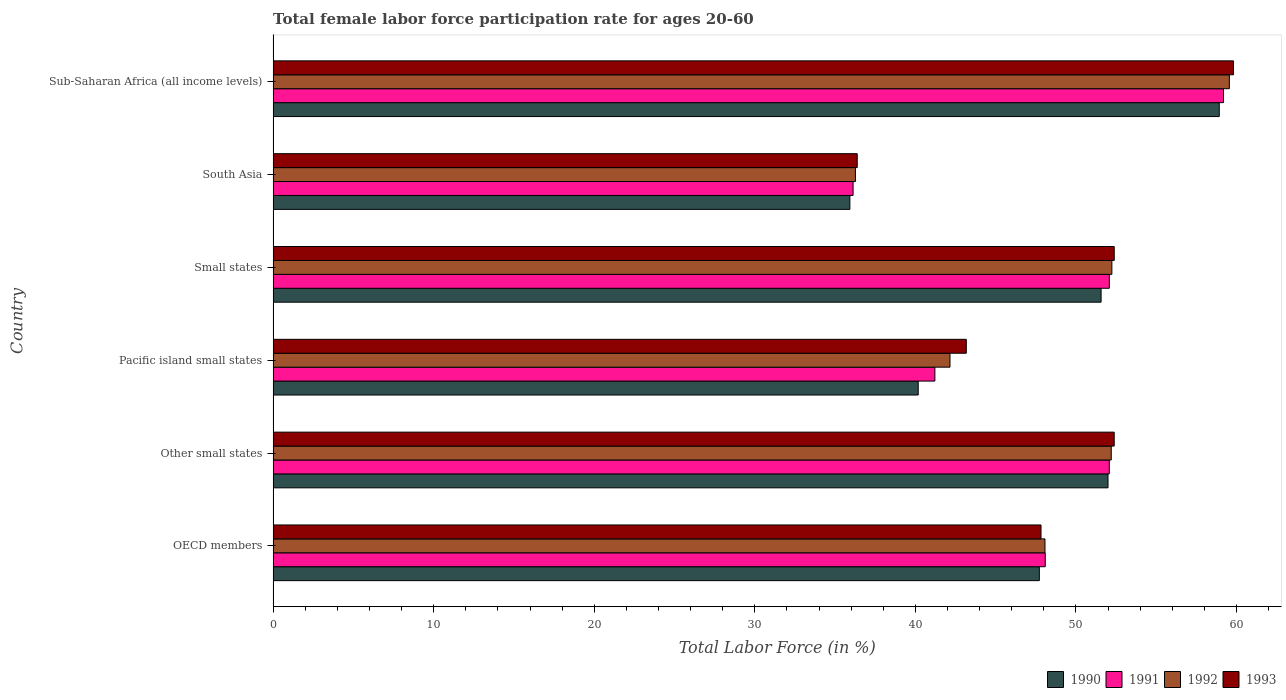How many different coloured bars are there?
Provide a short and direct response. 4. How many groups of bars are there?
Offer a terse response. 6. Are the number of bars on each tick of the Y-axis equal?
Provide a short and direct response. Yes. How many bars are there on the 3rd tick from the top?
Give a very brief answer. 4. How many bars are there on the 3rd tick from the bottom?
Your response must be concise. 4. What is the label of the 4th group of bars from the top?
Keep it short and to the point. Pacific island small states. In how many cases, is the number of bars for a given country not equal to the number of legend labels?
Offer a very short reply. 0. What is the female labor force participation rate in 1992 in OECD members?
Provide a succinct answer. 48.07. Across all countries, what is the maximum female labor force participation rate in 1991?
Give a very brief answer. 59.19. Across all countries, what is the minimum female labor force participation rate in 1992?
Your answer should be compact. 36.27. In which country was the female labor force participation rate in 1992 maximum?
Ensure brevity in your answer.  Sub-Saharan Africa (all income levels). What is the total female labor force participation rate in 1993 in the graph?
Provide a succinct answer. 291.94. What is the difference between the female labor force participation rate in 1993 in Small states and that in Sub-Saharan Africa (all income levels)?
Your answer should be compact. -7.43. What is the difference between the female labor force participation rate in 1990 in South Asia and the female labor force participation rate in 1993 in Sub-Saharan Africa (all income levels)?
Keep it short and to the point. -23.89. What is the average female labor force participation rate in 1992 per country?
Give a very brief answer. 48.41. What is the difference between the female labor force participation rate in 1993 and female labor force participation rate in 1992 in OECD members?
Keep it short and to the point. -0.25. What is the ratio of the female labor force participation rate in 1990 in OECD members to that in Pacific island small states?
Provide a succinct answer. 1.19. Is the female labor force participation rate in 1992 in OECD members less than that in South Asia?
Provide a succinct answer. No. What is the difference between the highest and the second highest female labor force participation rate in 1991?
Offer a terse response. 7.11. What is the difference between the highest and the lowest female labor force participation rate in 1990?
Your answer should be very brief. 23.01. In how many countries, is the female labor force participation rate in 1990 greater than the average female labor force participation rate in 1990 taken over all countries?
Offer a terse response. 4. Is the sum of the female labor force participation rate in 1992 in OECD members and Other small states greater than the maximum female labor force participation rate in 1990 across all countries?
Offer a terse response. Yes. What does the 1st bar from the top in Pacific island small states represents?
Your answer should be very brief. 1993. What does the 4th bar from the bottom in Pacific island small states represents?
Provide a short and direct response. 1993. Is it the case that in every country, the sum of the female labor force participation rate in 1990 and female labor force participation rate in 1993 is greater than the female labor force participation rate in 1991?
Keep it short and to the point. Yes. How many bars are there?
Give a very brief answer. 24. Are all the bars in the graph horizontal?
Keep it short and to the point. Yes. How many countries are there in the graph?
Provide a short and direct response. 6. What is the difference between two consecutive major ticks on the X-axis?
Your answer should be compact. 10. How many legend labels are there?
Keep it short and to the point. 4. How are the legend labels stacked?
Provide a short and direct response. Horizontal. What is the title of the graph?
Make the answer very short. Total female labor force participation rate for ages 20-60. What is the label or title of the Y-axis?
Give a very brief answer. Country. What is the Total Labor Force (in %) of 1990 in OECD members?
Give a very brief answer. 47.72. What is the Total Labor Force (in %) of 1991 in OECD members?
Your response must be concise. 48.09. What is the Total Labor Force (in %) in 1992 in OECD members?
Your response must be concise. 48.07. What is the Total Labor Force (in %) of 1993 in OECD members?
Offer a very short reply. 47.82. What is the Total Labor Force (in %) of 1990 in Other small states?
Ensure brevity in your answer.  52. What is the Total Labor Force (in %) in 1991 in Other small states?
Offer a very short reply. 52.08. What is the Total Labor Force (in %) in 1992 in Other small states?
Give a very brief answer. 52.2. What is the Total Labor Force (in %) of 1993 in Other small states?
Your answer should be compact. 52.38. What is the Total Labor Force (in %) in 1990 in Pacific island small states?
Provide a succinct answer. 40.18. What is the Total Labor Force (in %) in 1991 in Pacific island small states?
Offer a terse response. 41.21. What is the Total Labor Force (in %) of 1992 in Pacific island small states?
Ensure brevity in your answer.  42.15. What is the Total Labor Force (in %) in 1993 in Pacific island small states?
Provide a short and direct response. 43.17. What is the Total Labor Force (in %) of 1990 in Small states?
Make the answer very short. 51.57. What is the Total Labor Force (in %) of 1991 in Small states?
Your answer should be compact. 52.08. What is the Total Labor Force (in %) in 1992 in Small states?
Your answer should be compact. 52.24. What is the Total Labor Force (in %) in 1993 in Small states?
Your response must be concise. 52.38. What is the Total Labor Force (in %) in 1990 in South Asia?
Your answer should be very brief. 35.92. What is the Total Labor Force (in %) in 1991 in South Asia?
Provide a short and direct response. 36.12. What is the Total Labor Force (in %) in 1992 in South Asia?
Make the answer very short. 36.27. What is the Total Labor Force (in %) of 1993 in South Asia?
Ensure brevity in your answer.  36.38. What is the Total Labor Force (in %) of 1990 in Sub-Saharan Africa (all income levels)?
Keep it short and to the point. 58.92. What is the Total Labor Force (in %) in 1991 in Sub-Saharan Africa (all income levels)?
Your response must be concise. 59.19. What is the Total Labor Force (in %) of 1992 in Sub-Saharan Africa (all income levels)?
Ensure brevity in your answer.  59.55. What is the Total Labor Force (in %) in 1993 in Sub-Saharan Africa (all income levels)?
Give a very brief answer. 59.81. Across all countries, what is the maximum Total Labor Force (in %) of 1990?
Provide a succinct answer. 58.92. Across all countries, what is the maximum Total Labor Force (in %) in 1991?
Offer a terse response. 59.19. Across all countries, what is the maximum Total Labor Force (in %) of 1992?
Keep it short and to the point. 59.55. Across all countries, what is the maximum Total Labor Force (in %) of 1993?
Offer a very short reply. 59.81. Across all countries, what is the minimum Total Labor Force (in %) of 1990?
Provide a succinct answer. 35.92. Across all countries, what is the minimum Total Labor Force (in %) in 1991?
Your answer should be very brief. 36.12. Across all countries, what is the minimum Total Labor Force (in %) in 1992?
Provide a succinct answer. 36.27. Across all countries, what is the minimum Total Labor Force (in %) of 1993?
Offer a very short reply. 36.38. What is the total Total Labor Force (in %) of 1990 in the graph?
Your answer should be compact. 286.3. What is the total Total Labor Force (in %) of 1991 in the graph?
Provide a succinct answer. 288.76. What is the total Total Labor Force (in %) of 1992 in the graph?
Make the answer very short. 290.48. What is the total Total Labor Force (in %) in 1993 in the graph?
Your answer should be very brief. 291.94. What is the difference between the Total Labor Force (in %) in 1990 in OECD members and that in Other small states?
Your answer should be very brief. -4.28. What is the difference between the Total Labor Force (in %) in 1991 in OECD members and that in Other small states?
Keep it short and to the point. -3.99. What is the difference between the Total Labor Force (in %) of 1992 in OECD members and that in Other small states?
Ensure brevity in your answer.  -4.13. What is the difference between the Total Labor Force (in %) in 1993 in OECD members and that in Other small states?
Offer a terse response. -4.56. What is the difference between the Total Labor Force (in %) in 1990 in OECD members and that in Pacific island small states?
Your answer should be compact. 7.54. What is the difference between the Total Labor Force (in %) of 1991 in OECD members and that in Pacific island small states?
Your response must be concise. 6.87. What is the difference between the Total Labor Force (in %) in 1992 in OECD members and that in Pacific island small states?
Provide a short and direct response. 5.92. What is the difference between the Total Labor Force (in %) in 1993 in OECD members and that in Pacific island small states?
Give a very brief answer. 4.65. What is the difference between the Total Labor Force (in %) in 1990 in OECD members and that in Small states?
Make the answer very short. -3.85. What is the difference between the Total Labor Force (in %) of 1991 in OECD members and that in Small states?
Your response must be concise. -3.99. What is the difference between the Total Labor Force (in %) in 1992 in OECD members and that in Small states?
Keep it short and to the point. -4.17. What is the difference between the Total Labor Force (in %) of 1993 in OECD members and that in Small states?
Your answer should be very brief. -4.56. What is the difference between the Total Labor Force (in %) in 1990 in OECD members and that in South Asia?
Ensure brevity in your answer.  11.8. What is the difference between the Total Labor Force (in %) of 1991 in OECD members and that in South Asia?
Your answer should be compact. 11.97. What is the difference between the Total Labor Force (in %) in 1992 in OECD members and that in South Asia?
Ensure brevity in your answer.  11.8. What is the difference between the Total Labor Force (in %) in 1993 in OECD members and that in South Asia?
Offer a very short reply. 11.45. What is the difference between the Total Labor Force (in %) in 1990 in OECD members and that in Sub-Saharan Africa (all income levels)?
Ensure brevity in your answer.  -11.21. What is the difference between the Total Labor Force (in %) of 1991 in OECD members and that in Sub-Saharan Africa (all income levels)?
Offer a very short reply. -11.1. What is the difference between the Total Labor Force (in %) of 1992 in OECD members and that in Sub-Saharan Africa (all income levels)?
Your answer should be compact. -11.48. What is the difference between the Total Labor Force (in %) of 1993 in OECD members and that in Sub-Saharan Africa (all income levels)?
Your response must be concise. -11.99. What is the difference between the Total Labor Force (in %) of 1990 in Other small states and that in Pacific island small states?
Your answer should be compact. 11.82. What is the difference between the Total Labor Force (in %) of 1991 in Other small states and that in Pacific island small states?
Make the answer very short. 10.86. What is the difference between the Total Labor Force (in %) of 1992 in Other small states and that in Pacific island small states?
Your response must be concise. 10.04. What is the difference between the Total Labor Force (in %) in 1993 in Other small states and that in Pacific island small states?
Make the answer very short. 9.21. What is the difference between the Total Labor Force (in %) in 1990 in Other small states and that in Small states?
Give a very brief answer. 0.43. What is the difference between the Total Labor Force (in %) of 1991 in Other small states and that in Small states?
Provide a short and direct response. -0. What is the difference between the Total Labor Force (in %) of 1992 in Other small states and that in Small states?
Ensure brevity in your answer.  -0.04. What is the difference between the Total Labor Force (in %) in 1993 in Other small states and that in Small states?
Your response must be concise. -0. What is the difference between the Total Labor Force (in %) in 1990 in Other small states and that in South Asia?
Your answer should be very brief. 16.08. What is the difference between the Total Labor Force (in %) in 1991 in Other small states and that in South Asia?
Provide a succinct answer. 15.96. What is the difference between the Total Labor Force (in %) of 1992 in Other small states and that in South Asia?
Provide a succinct answer. 15.93. What is the difference between the Total Labor Force (in %) in 1993 in Other small states and that in South Asia?
Your response must be concise. 16. What is the difference between the Total Labor Force (in %) of 1990 in Other small states and that in Sub-Saharan Africa (all income levels)?
Your response must be concise. -6.93. What is the difference between the Total Labor Force (in %) in 1991 in Other small states and that in Sub-Saharan Africa (all income levels)?
Keep it short and to the point. -7.11. What is the difference between the Total Labor Force (in %) in 1992 in Other small states and that in Sub-Saharan Africa (all income levels)?
Ensure brevity in your answer.  -7.36. What is the difference between the Total Labor Force (in %) in 1993 in Other small states and that in Sub-Saharan Africa (all income levels)?
Your response must be concise. -7.43. What is the difference between the Total Labor Force (in %) in 1990 in Pacific island small states and that in Small states?
Make the answer very short. -11.39. What is the difference between the Total Labor Force (in %) in 1991 in Pacific island small states and that in Small states?
Your response must be concise. -10.86. What is the difference between the Total Labor Force (in %) in 1992 in Pacific island small states and that in Small states?
Keep it short and to the point. -10.08. What is the difference between the Total Labor Force (in %) in 1993 in Pacific island small states and that in Small states?
Give a very brief answer. -9.21. What is the difference between the Total Labor Force (in %) of 1990 in Pacific island small states and that in South Asia?
Offer a terse response. 4.26. What is the difference between the Total Labor Force (in %) in 1991 in Pacific island small states and that in South Asia?
Provide a succinct answer. 5.1. What is the difference between the Total Labor Force (in %) in 1992 in Pacific island small states and that in South Asia?
Give a very brief answer. 5.89. What is the difference between the Total Labor Force (in %) in 1993 in Pacific island small states and that in South Asia?
Your response must be concise. 6.79. What is the difference between the Total Labor Force (in %) in 1990 in Pacific island small states and that in Sub-Saharan Africa (all income levels)?
Make the answer very short. -18.75. What is the difference between the Total Labor Force (in %) of 1991 in Pacific island small states and that in Sub-Saharan Africa (all income levels)?
Provide a short and direct response. -17.97. What is the difference between the Total Labor Force (in %) in 1992 in Pacific island small states and that in Sub-Saharan Africa (all income levels)?
Offer a very short reply. -17.4. What is the difference between the Total Labor Force (in %) of 1993 in Pacific island small states and that in Sub-Saharan Africa (all income levels)?
Provide a short and direct response. -16.64. What is the difference between the Total Labor Force (in %) in 1990 in Small states and that in South Asia?
Make the answer very short. 15.65. What is the difference between the Total Labor Force (in %) in 1991 in Small states and that in South Asia?
Provide a short and direct response. 15.96. What is the difference between the Total Labor Force (in %) in 1992 in Small states and that in South Asia?
Give a very brief answer. 15.97. What is the difference between the Total Labor Force (in %) in 1993 in Small states and that in South Asia?
Give a very brief answer. 16.01. What is the difference between the Total Labor Force (in %) in 1990 in Small states and that in Sub-Saharan Africa (all income levels)?
Give a very brief answer. -7.36. What is the difference between the Total Labor Force (in %) in 1991 in Small states and that in Sub-Saharan Africa (all income levels)?
Offer a very short reply. -7.11. What is the difference between the Total Labor Force (in %) of 1992 in Small states and that in Sub-Saharan Africa (all income levels)?
Give a very brief answer. -7.32. What is the difference between the Total Labor Force (in %) of 1993 in Small states and that in Sub-Saharan Africa (all income levels)?
Offer a terse response. -7.43. What is the difference between the Total Labor Force (in %) of 1990 in South Asia and that in Sub-Saharan Africa (all income levels)?
Provide a short and direct response. -23.01. What is the difference between the Total Labor Force (in %) of 1991 in South Asia and that in Sub-Saharan Africa (all income levels)?
Give a very brief answer. -23.07. What is the difference between the Total Labor Force (in %) of 1992 in South Asia and that in Sub-Saharan Africa (all income levels)?
Offer a very short reply. -23.29. What is the difference between the Total Labor Force (in %) of 1993 in South Asia and that in Sub-Saharan Africa (all income levels)?
Your answer should be very brief. -23.43. What is the difference between the Total Labor Force (in %) in 1990 in OECD members and the Total Labor Force (in %) in 1991 in Other small states?
Give a very brief answer. -4.36. What is the difference between the Total Labor Force (in %) of 1990 in OECD members and the Total Labor Force (in %) of 1992 in Other small states?
Offer a very short reply. -4.48. What is the difference between the Total Labor Force (in %) of 1990 in OECD members and the Total Labor Force (in %) of 1993 in Other small states?
Keep it short and to the point. -4.66. What is the difference between the Total Labor Force (in %) in 1991 in OECD members and the Total Labor Force (in %) in 1992 in Other small states?
Keep it short and to the point. -4.11. What is the difference between the Total Labor Force (in %) in 1991 in OECD members and the Total Labor Force (in %) in 1993 in Other small states?
Your answer should be compact. -4.29. What is the difference between the Total Labor Force (in %) of 1992 in OECD members and the Total Labor Force (in %) of 1993 in Other small states?
Ensure brevity in your answer.  -4.31. What is the difference between the Total Labor Force (in %) of 1990 in OECD members and the Total Labor Force (in %) of 1991 in Pacific island small states?
Make the answer very short. 6.5. What is the difference between the Total Labor Force (in %) of 1990 in OECD members and the Total Labor Force (in %) of 1992 in Pacific island small states?
Provide a short and direct response. 5.57. What is the difference between the Total Labor Force (in %) in 1990 in OECD members and the Total Labor Force (in %) in 1993 in Pacific island small states?
Your answer should be very brief. 4.55. What is the difference between the Total Labor Force (in %) of 1991 in OECD members and the Total Labor Force (in %) of 1992 in Pacific island small states?
Keep it short and to the point. 5.93. What is the difference between the Total Labor Force (in %) in 1991 in OECD members and the Total Labor Force (in %) in 1993 in Pacific island small states?
Provide a succinct answer. 4.92. What is the difference between the Total Labor Force (in %) of 1992 in OECD members and the Total Labor Force (in %) of 1993 in Pacific island small states?
Your response must be concise. 4.9. What is the difference between the Total Labor Force (in %) in 1990 in OECD members and the Total Labor Force (in %) in 1991 in Small states?
Provide a short and direct response. -4.36. What is the difference between the Total Labor Force (in %) in 1990 in OECD members and the Total Labor Force (in %) in 1992 in Small states?
Your response must be concise. -4.52. What is the difference between the Total Labor Force (in %) in 1990 in OECD members and the Total Labor Force (in %) in 1993 in Small states?
Make the answer very short. -4.66. What is the difference between the Total Labor Force (in %) of 1991 in OECD members and the Total Labor Force (in %) of 1992 in Small states?
Keep it short and to the point. -4.15. What is the difference between the Total Labor Force (in %) in 1991 in OECD members and the Total Labor Force (in %) in 1993 in Small states?
Provide a succinct answer. -4.29. What is the difference between the Total Labor Force (in %) in 1992 in OECD members and the Total Labor Force (in %) in 1993 in Small states?
Ensure brevity in your answer.  -4.31. What is the difference between the Total Labor Force (in %) in 1990 in OECD members and the Total Labor Force (in %) in 1991 in South Asia?
Give a very brief answer. 11.6. What is the difference between the Total Labor Force (in %) of 1990 in OECD members and the Total Labor Force (in %) of 1992 in South Asia?
Provide a short and direct response. 11.45. What is the difference between the Total Labor Force (in %) of 1990 in OECD members and the Total Labor Force (in %) of 1993 in South Asia?
Offer a very short reply. 11.34. What is the difference between the Total Labor Force (in %) of 1991 in OECD members and the Total Labor Force (in %) of 1992 in South Asia?
Make the answer very short. 11.82. What is the difference between the Total Labor Force (in %) of 1991 in OECD members and the Total Labor Force (in %) of 1993 in South Asia?
Ensure brevity in your answer.  11.71. What is the difference between the Total Labor Force (in %) in 1992 in OECD members and the Total Labor Force (in %) in 1993 in South Asia?
Provide a succinct answer. 11.69. What is the difference between the Total Labor Force (in %) of 1990 in OECD members and the Total Labor Force (in %) of 1991 in Sub-Saharan Africa (all income levels)?
Your answer should be compact. -11.47. What is the difference between the Total Labor Force (in %) of 1990 in OECD members and the Total Labor Force (in %) of 1992 in Sub-Saharan Africa (all income levels)?
Keep it short and to the point. -11.83. What is the difference between the Total Labor Force (in %) of 1990 in OECD members and the Total Labor Force (in %) of 1993 in Sub-Saharan Africa (all income levels)?
Provide a succinct answer. -12.09. What is the difference between the Total Labor Force (in %) in 1991 in OECD members and the Total Labor Force (in %) in 1992 in Sub-Saharan Africa (all income levels)?
Your response must be concise. -11.46. What is the difference between the Total Labor Force (in %) of 1991 in OECD members and the Total Labor Force (in %) of 1993 in Sub-Saharan Africa (all income levels)?
Your response must be concise. -11.72. What is the difference between the Total Labor Force (in %) of 1992 in OECD members and the Total Labor Force (in %) of 1993 in Sub-Saharan Africa (all income levels)?
Provide a succinct answer. -11.74. What is the difference between the Total Labor Force (in %) in 1990 in Other small states and the Total Labor Force (in %) in 1991 in Pacific island small states?
Your response must be concise. 10.78. What is the difference between the Total Labor Force (in %) in 1990 in Other small states and the Total Labor Force (in %) in 1992 in Pacific island small states?
Your answer should be compact. 9.84. What is the difference between the Total Labor Force (in %) of 1990 in Other small states and the Total Labor Force (in %) of 1993 in Pacific island small states?
Offer a terse response. 8.83. What is the difference between the Total Labor Force (in %) of 1991 in Other small states and the Total Labor Force (in %) of 1992 in Pacific island small states?
Your response must be concise. 9.92. What is the difference between the Total Labor Force (in %) in 1991 in Other small states and the Total Labor Force (in %) in 1993 in Pacific island small states?
Make the answer very short. 8.91. What is the difference between the Total Labor Force (in %) of 1992 in Other small states and the Total Labor Force (in %) of 1993 in Pacific island small states?
Make the answer very short. 9.03. What is the difference between the Total Labor Force (in %) in 1990 in Other small states and the Total Labor Force (in %) in 1991 in Small states?
Your response must be concise. -0.08. What is the difference between the Total Labor Force (in %) in 1990 in Other small states and the Total Labor Force (in %) in 1992 in Small states?
Keep it short and to the point. -0.24. What is the difference between the Total Labor Force (in %) of 1990 in Other small states and the Total Labor Force (in %) of 1993 in Small states?
Your response must be concise. -0.39. What is the difference between the Total Labor Force (in %) in 1991 in Other small states and the Total Labor Force (in %) in 1992 in Small states?
Your answer should be compact. -0.16. What is the difference between the Total Labor Force (in %) in 1991 in Other small states and the Total Labor Force (in %) in 1993 in Small states?
Make the answer very short. -0.31. What is the difference between the Total Labor Force (in %) of 1992 in Other small states and the Total Labor Force (in %) of 1993 in Small states?
Your answer should be very brief. -0.19. What is the difference between the Total Labor Force (in %) of 1990 in Other small states and the Total Labor Force (in %) of 1991 in South Asia?
Ensure brevity in your answer.  15.88. What is the difference between the Total Labor Force (in %) of 1990 in Other small states and the Total Labor Force (in %) of 1992 in South Asia?
Provide a short and direct response. 15.73. What is the difference between the Total Labor Force (in %) in 1990 in Other small states and the Total Labor Force (in %) in 1993 in South Asia?
Give a very brief answer. 15.62. What is the difference between the Total Labor Force (in %) of 1991 in Other small states and the Total Labor Force (in %) of 1992 in South Asia?
Make the answer very short. 15.81. What is the difference between the Total Labor Force (in %) in 1991 in Other small states and the Total Labor Force (in %) in 1993 in South Asia?
Ensure brevity in your answer.  15.7. What is the difference between the Total Labor Force (in %) of 1992 in Other small states and the Total Labor Force (in %) of 1993 in South Asia?
Provide a short and direct response. 15.82. What is the difference between the Total Labor Force (in %) in 1990 in Other small states and the Total Labor Force (in %) in 1991 in Sub-Saharan Africa (all income levels)?
Ensure brevity in your answer.  -7.19. What is the difference between the Total Labor Force (in %) in 1990 in Other small states and the Total Labor Force (in %) in 1992 in Sub-Saharan Africa (all income levels)?
Your answer should be compact. -7.56. What is the difference between the Total Labor Force (in %) in 1990 in Other small states and the Total Labor Force (in %) in 1993 in Sub-Saharan Africa (all income levels)?
Offer a terse response. -7.81. What is the difference between the Total Labor Force (in %) of 1991 in Other small states and the Total Labor Force (in %) of 1992 in Sub-Saharan Africa (all income levels)?
Provide a succinct answer. -7.48. What is the difference between the Total Labor Force (in %) in 1991 in Other small states and the Total Labor Force (in %) in 1993 in Sub-Saharan Africa (all income levels)?
Keep it short and to the point. -7.73. What is the difference between the Total Labor Force (in %) in 1992 in Other small states and the Total Labor Force (in %) in 1993 in Sub-Saharan Africa (all income levels)?
Your response must be concise. -7.61. What is the difference between the Total Labor Force (in %) in 1990 in Pacific island small states and the Total Labor Force (in %) in 1991 in Small states?
Offer a terse response. -11.9. What is the difference between the Total Labor Force (in %) in 1990 in Pacific island small states and the Total Labor Force (in %) in 1992 in Small states?
Keep it short and to the point. -12.06. What is the difference between the Total Labor Force (in %) in 1990 in Pacific island small states and the Total Labor Force (in %) in 1993 in Small states?
Offer a terse response. -12.21. What is the difference between the Total Labor Force (in %) of 1991 in Pacific island small states and the Total Labor Force (in %) of 1992 in Small states?
Offer a terse response. -11.02. What is the difference between the Total Labor Force (in %) in 1991 in Pacific island small states and the Total Labor Force (in %) in 1993 in Small states?
Provide a short and direct response. -11.17. What is the difference between the Total Labor Force (in %) in 1992 in Pacific island small states and the Total Labor Force (in %) in 1993 in Small states?
Ensure brevity in your answer.  -10.23. What is the difference between the Total Labor Force (in %) of 1990 in Pacific island small states and the Total Labor Force (in %) of 1991 in South Asia?
Provide a short and direct response. 4.06. What is the difference between the Total Labor Force (in %) in 1990 in Pacific island small states and the Total Labor Force (in %) in 1992 in South Asia?
Your response must be concise. 3.91. What is the difference between the Total Labor Force (in %) of 1990 in Pacific island small states and the Total Labor Force (in %) of 1993 in South Asia?
Offer a very short reply. 3.8. What is the difference between the Total Labor Force (in %) of 1991 in Pacific island small states and the Total Labor Force (in %) of 1992 in South Asia?
Offer a very short reply. 4.95. What is the difference between the Total Labor Force (in %) in 1991 in Pacific island small states and the Total Labor Force (in %) in 1993 in South Asia?
Give a very brief answer. 4.84. What is the difference between the Total Labor Force (in %) in 1992 in Pacific island small states and the Total Labor Force (in %) in 1993 in South Asia?
Provide a short and direct response. 5.78. What is the difference between the Total Labor Force (in %) of 1990 in Pacific island small states and the Total Labor Force (in %) of 1991 in Sub-Saharan Africa (all income levels)?
Your answer should be very brief. -19.01. What is the difference between the Total Labor Force (in %) of 1990 in Pacific island small states and the Total Labor Force (in %) of 1992 in Sub-Saharan Africa (all income levels)?
Provide a short and direct response. -19.38. What is the difference between the Total Labor Force (in %) in 1990 in Pacific island small states and the Total Labor Force (in %) in 1993 in Sub-Saharan Africa (all income levels)?
Your answer should be very brief. -19.63. What is the difference between the Total Labor Force (in %) of 1991 in Pacific island small states and the Total Labor Force (in %) of 1992 in Sub-Saharan Africa (all income levels)?
Give a very brief answer. -18.34. What is the difference between the Total Labor Force (in %) of 1991 in Pacific island small states and the Total Labor Force (in %) of 1993 in Sub-Saharan Africa (all income levels)?
Provide a succinct answer. -18.59. What is the difference between the Total Labor Force (in %) of 1992 in Pacific island small states and the Total Labor Force (in %) of 1993 in Sub-Saharan Africa (all income levels)?
Your response must be concise. -17.66. What is the difference between the Total Labor Force (in %) of 1990 in Small states and the Total Labor Force (in %) of 1991 in South Asia?
Your answer should be very brief. 15.45. What is the difference between the Total Labor Force (in %) of 1990 in Small states and the Total Labor Force (in %) of 1992 in South Asia?
Make the answer very short. 15.3. What is the difference between the Total Labor Force (in %) in 1990 in Small states and the Total Labor Force (in %) in 1993 in South Asia?
Provide a short and direct response. 15.19. What is the difference between the Total Labor Force (in %) in 1991 in Small states and the Total Labor Force (in %) in 1992 in South Asia?
Give a very brief answer. 15.81. What is the difference between the Total Labor Force (in %) in 1991 in Small states and the Total Labor Force (in %) in 1993 in South Asia?
Your answer should be compact. 15.7. What is the difference between the Total Labor Force (in %) in 1992 in Small states and the Total Labor Force (in %) in 1993 in South Asia?
Your answer should be compact. 15.86. What is the difference between the Total Labor Force (in %) of 1990 in Small states and the Total Labor Force (in %) of 1991 in Sub-Saharan Africa (all income levels)?
Offer a very short reply. -7.62. What is the difference between the Total Labor Force (in %) of 1990 in Small states and the Total Labor Force (in %) of 1992 in Sub-Saharan Africa (all income levels)?
Provide a succinct answer. -7.99. What is the difference between the Total Labor Force (in %) of 1990 in Small states and the Total Labor Force (in %) of 1993 in Sub-Saharan Africa (all income levels)?
Your answer should be very brief. -8.24. What is the difference between the Total Labor Force (in %) in 1991 in Small states and the Total Labor Force (in %) in 1992 in Sub-Saharan Africa (all income levels)?
Make the answer very short. -7.47. What is the difference between the Total Labor Force (in %) of 1991 in Small states and the Total Labor Force (in %) of 1993 in Sub-Saharan Africa (all income levels)?
Keep it short and to the point. -7.73. What is the difference between the Total Labor Force (in %) of 1992 in Small states and the Total Labor Force (in %) of 1993 in Sub-Saharan Africa (all income levels)?
Provide a succinct answer. -7.57. What is the difference between the Total Labor Force (in %) in 1990 in South Asia and the Total Labor Force (in %) in 1991 in Sub-Saharan Africa (all income levels)?
Provide a succinct answer. -23.27. What is the difference between the Total Labor Force (in %) in 1990 in South Asia and the Total Labor Force (in %) in 1992 in Sub-Saharan Africa (all income levels)?
Your response must be concise. -23.63. What is the difference between the Total Labor Force (in %) in 1990 in South Asia and the Total Labor Force (in %) in 1993 in Sub-Saharan Africa (all income levels)?
Make the answer very short. -23.89. What is the difference between the Total Labor Force (in %) in 1991 in South Asia and the Total Labor Force (in %) in 1992 in Sub-Saharan Africa (all income levels)?
Offer a very short reply. -23.43. What is the difference between the Total Labor Force (in %) of 1991 in South Asia and the Total Labor Force (in %) of 1993 in Sub-Saharan Africa (all income levels)?
Keep it short and to the point. -23.69. What is the difference between the Total Labor Force (in %) of 1992 in South Asia and the Total Labor Force (in %) of 1993 in Sub-Saharan Africa (all income levels)?
Your response must be concise. -23.54. What is the average Total Labor Force (in %) in 1990 per country?
Your response must be concise. 47.72. What is the average Total Labor Force (in %) of 1991 per country?
Your answer should be compact. 48.13. What is the average Total Labor Force (in %) in 1992 per country?
Your answer should be compact. 48.41. What is the average Total Labor Force (in %) in 1993 per country?
Your answer should be very brief. 48.66. What is the difference between the Total Labor Force (in %) in 1990 and Total Labor Force (in %) in 1991 in OECD members?
Ensure brevity in your answer.  -0.37. What is the difference between the Total Labor Force (in %) of 1990 and Total Labor Force (in %) of 1992 in OECD members?
Ensure brevity in your answer.  -0.35. What is the difference between the Total Labor Force (in %) of 1990 and Total Labor Force (in %) of 1993 in OECD members?
Your response must be concise. -0.1. What is the difference between the Total Labor Force (in %) in 1991 and Total Labor Force (in %) in 1992 in OECD members?
Keep it short and to the point. 0.02. What is the difference between the Total Labor Force (in %) of 1991 and Total Labor Force (in %) of 1993 in OECD members?
Give a very brief answer. 0.27. What is the difference between the Total Labor Force (in %) of 1992 and Total Labor Force (in %) of 1993 in OECD members?
Make the answer very short. 0.25. What is the difference between the Total Labor Force (in %) of 1990 and Total Labor Force (in %) of 1991 in Other small states?
Offer a very short reply. -0.08. What is the difference between the Total Labor Force (in %) of 1990 and Total Labor Force (in %) of 1992 in Other small states?
Ensure brevity in your answer.  -0.2. What is the difference between the Total Labor Force (in %) in 1990 and Total Labor Force (in %) in 1993 in Other small states?
Offer a terse response. -0.39. What is the difference between the Total Labor Force (in %) of 1991 and Total Labor Force (in %) of 1992 in Other small states?
Provide a succinct answer. -0.12. What is the difference between the Total Labor Force (in %) of 1991 and Total Labor Force (in %) of 1993 in Other small states?
Make the answer very short. -0.31. What is the difference between the Total Labor Force (in %) of 1992 and Total Labor Force (in %) of 1993 in Other small states?
Make the answer very short. -0.18. What is the difference between the Total Labor Force (in %) in 1990 and Total Labor Force (in %) in 1991 in Pacific island small states?
Give a very brief answer. -1.04. What is the difference between the Total Labor Force (in %) in 1990 and Total Labor Force (in %) in 1992 in Pacific island small states?
Your answer should be compact. -1.98. What is the difference between the Total Labor Force (in %) of 1990 and Total Labor Force (in %) of 1993 in Pacific island small states?
Make the answer very short. -2.99. What is the difference between the Total Labor Force (in %) of 1991 and Total Labor Force (in %) of 1992 in Pacific island small states?
Provide a succinct answer. -0.94. What is the difference between the Total Labor Force (in %) of 1991 and Total Labor Force (in %) of 1993 in Pacific island small states?
Provide a succinct answer. -1.96. What is the difference between the Total Labor Force (in %) in 1992 and Total Labor Force (in %) in 1993 in Pacific island small states?
Ensure brevity in your answer.  -1.02. What is the difference between the Total Labor Force (in %) of 1990 and Total Labor Force (in %) of 1991 in Small states?
Provide a short and direct response. -0.51. What is the difference between the Total Labor Force (in %) in 1990 and Total Labor Force (in %) in 1992 in Small states?
Make the answer very short. -0.67. What is the difference between the Total Labor Force (in %) of 1990 and Total Labor Force (in %) of 1993 in Small states?
Make the answer very short. -0.82. What is the difference between the Total Labor Force (in %) in 1991 and Total Labor Force (in %) in 1992 in Small states?
Offer a very short reply. -0.16. What is the difference between the Total Labor Force (in %) in 1991 and Total Labor Force (in %) in 1993 in Small states?
Give a very brief answer. -0.3. What is the difference between the Total Labor Force (in %) of 1992 and Total Labor Force (in %) of 1993 in Small states?
Your answer should be compact. -0.15. What is the difference between the Total Labor Force (in %) in 1990 and Total Labor Force (in %) in 1991 in South Asia?
Give a very brief answer. -0.2. What is the difference between the Total Labor Force (in %) of 1990 and Total Labor Force (in %) of 1992 in South Asia?
Offer a terse response. -0.35. What is the difference between the Total Labor Force (in %) in 1990 and Total Labor Force (in %) in 1993 in South Asia?
Provide a succinct answer. -0.46. What is the difference between the Total Labor Force (in %) of 1991 and Total Labor Force (in %) of 1992 in South Asia?
Give a very brief answer. -0.15. What is the difference between the Total Labor Force (in %) of 1991 and Total Labor Force (in %) of 1993 in South Asia?
Offer a very short reply. -0.26. What is the difference between the Total Labor Force (in %) in 1992 and Total Labor Force (in %) in 1993 in South Asia?
Make the answer very short. -0.11. What is the difference between the Total Labor Force (in %) of 1990 and Total Labor Force (in %) of 1991 in Sub-Saharan Africa (all income levels)?
Keep it short and to the point. -0.26. What is the difference between the Total Labor Force (in %) in 1990 and Total Labor Force (in %) in 1992 in Sub-Saharan Africa (all income levels)?
Make the answer very short. -0.63. What is the difference between the Total Labor Force (in %) in 1990 and Total Labor Force (in %) in 1993 in Sub-Saharan Africa (all income levels)?
Your response must be concise. -0.88. What is the difference between the Total Labor Force (in %) in 1991 and Total Labor Force (in %) in 1992 in Sub-Saharan Africa (all income levels)?
Provide a short and direct response. -0.36. What is the difference between the Total Labor Force (in %) of 1991 and Total Labor Force (in %) of 1993 in Sub-Saharan Africa (all income levels)?
Ensure brevity in your answer.  -0.62. What is the difference between the Total Labor Force (in %) in 1992 and Total Labor Force (in %) in 1993 in Sub-Saharan Africa (all income levels)?
Offer a terse response. -0.26. What is the ratio of the Total Labor Force (in %) in 1990 in OECD members to that in Other small states?
Provide a succinct answer. 0.92. What is the ratio of the Total Labor Force (in %) in 1991 in OECD members to that in Other small states?
Ensure brevity in your answer.  0.92. What is the ratio of the Total Labor Force (in %) in 1992 in OECD members to that in Other small states?
Make the answer very short. 0.92. What is the ratio of the Total Labor Force (in %) in 1993 in OECD members to that in Other small states?
Your answer should be very brief. 0.91. What is the ratio of the Total Labor Force (in %) in 1990 in OECD members to that in Pacific island small states?
Your answer should be very brief. 1.19. What is the ratio of the Total Labor Force (in %) of 1991 in OECD members to that in Pacific island small states?
Your answer should be compact. 1.17. What is the ratio of the Total Labor Force (in %) of 1992 in OECD members to that in Pacific island small states?
Your response must be concise. 1.14. What is the ratio of the Total Labor Force (in %) of 1993 in OECD members to that in Pacific island small states?
Ensure brevity in your answer.  1.11. What is the ratio of the Total Labor Force (in %) of 1990 in OECD members to that in Small states?
Offer a terse response. 0.93. What is the ratio of the Total Labor Force (in %) in 1991 in OECD members to that in Small states?
Your answer should be very brief. 0.92. What is the ratio of the Total Labor Force (in %) of 1992 in OECD members to that in Small states?
Make the answer very short. 0.92. What is the ratio of the Total Labor Force (in %) of 1993 in OECD members to that in Small states?
Offer a terse response. 0.91. What is the ratio of the Total Labor Force (in %) in 1990 in OECD members to that in South Asia?
Give a very brief answer. 1.33. What is the ratio of the Total Labor Force (in %) of 1991 in OECD members to that in South Asia?
Provide a succinct answer. 1.33. What is the ratio of the Total Labor Force (in %) in 1992 in OECD members to that in South Asia?
Give a very brief answer. 1.33. What is the ratio of the Total Labor Force (in %) in 1993 in OECD members to that in South Asia?
Provide a succinct answer. 1.31. What is the ratio of the Total Labor Force (in %) of 1990 in OECD members to that in Sub-Saharan Africa (all income levels)?
Your response must be concise. 0.81. What is the ratio of the Total Labor Force (in %) in 1991 in OECD members to that in Sub-Saharan Africa (all income levels)?
Your answer should be very brief. 0.81. What is the ratio of the Total Labor Force (in %) of 1992 in OECD members to that in Sub-Saharan Africa (all income levels)?
Keep it short and to the point. 0.81. What is the ratio of the Total Labor Force (in %) of 1993 in OECD members to that in Sub-Saharan Africa (all income levels)?
Give a very brief answer. 0.8. What is the ratio of the Total Labor Force (in %) in 1990 in Other small states to that in Pacific island small states?
Your answer should be compact. 1.29. What is the ratio of the Total Labor Force (in %) in 1991 in Other small states to that in Pacific island small states?
Provide a short and direct response. 1.26. What is the ratio of the Total Labor Force (in %) in 1992 in Other small states to that in Pacific island small states?
Your answer should be very brief. 1.24. What is the ratio of the Total Labor Force (in %) in 1993 in Other small states to that in Pacific island small states?
Provide a succinct answer. 1.21. What is the ratio of the Total Labor Force (in %) of 1990 in Other small states to that in Small states?
Ensure brevity in your answer.  1.01. What is the ratio of the Total Labor Force (in %) in 1990 in Other small states to that in South Asia?
Offer a very short reply. 1.45. What is the ratio of the Total Labor Force (in %) of 1991 in Other small states to that in South Asia?
Give a very brief answer. 1.44. What is the ratio of the Total Labor Force (in %) of 1992 in Other small states to that in South Asia?
Offer a terse response. 1.44. What is the ratio of the Total Labor Force (in %) of 1993 in Other small states to that in South Asia?
Ensure brevity in your answer.  1.44. What is the ratio of the Total Labor Force (in %) of 1990 in Other small states to that in Sub-Saharan Africa (all income levels)?
Make the answer very short. 0.88. What is the ratio of the Total Labor Force (in %) of 1991 in Other small states to that in Sub-Saharan Africa (all income levels)?
Your response must be concise. 0.88. What is the ratio of the Total Labor Force (in %) in 1992 in Other small states to that in Sub-Saharan Africa (all income levels)?
Offer a very short reply. 0.88. What is the ratio of the Total Labor Force (in %) in 1993 in Other small states to that in Sub-Saharan Africa (all income levels)?
Ensure brevity in your answer.  0.88. What is the ratio of the Total Labor Force (in %) in 1990 in Pacific island small states to that in Small states?
Provide a short and direct response. 0.78. What is the ratio of the Total Labor Force (in %) of 1991 in Pacific island small states to that in Small states?
Your response must be concise. 0.79. What is the ratio of the Total Labor Force (in %) of 1992 in Pacific island small states to that in Small states?
Keep it short and to the point. 0.81. What is the ratio of the Total Labor Force (in %) of 1993 in Pacific island small states to that in Small states?
Offer a terse response. 0.82. What is the ratio of the Total Labor Force (in %) of 1990 in Pacific island small states to that in South Asia?
Provide a succinct answer. 1.12. What is the ratio of the Total Labor Force (in %) of 1991 in Pacific island small states to that in South Asia?
Your answer should be compact. 1.14. What is the ratio of the Total Labor Force (in %) in 1992 in Pacific island small states to that in South Asia?
Your answer should be compact. 1.16. What is the ratio of the Total Labor Force (in %) in 1993 in Pacific island small states to that in South Asia?
Offer a very short reply. 1.19. What is the ratio of the Total Labor Force (in %) of 1990 in Pacific island small states to that in Sub-Saharan Africa (all income levels)?
Your answer should be very brief. 0.68. What is the ratio of the Total Labor Force (in %) in 1991 in Pacific island small states to that in Sub-Saharan Africa (all income levels)?
Ensure brevity in your answer.  0.7. What is the ratio of the Total Labor Force (in %) in 1992 in Pacific island small states to that in Sub-Saharan Africa (all income levels)?
Make the answer very short. 0.71. What is the ratio of the Total Labor Force (in %) of 1993 in Pacific island small states to that in Sub-Saharan Africa (all income levels)?
Your response must be concise. 0.72. What is the ratio of the Total Labor Force (in %) of 1990 in Small states to that in South Asia?
Offer a very short reply. 1.44. What is the ratio of the Total Labor Force (in %) of 1991 in Small states to that in South Asia?
Give a very brief answer. 1.44. What is the ratio of the Total Labor Force (in %) in 1992 in Small states to that in South Asia?
Offer a terse response. 1.44. What is the ratio of the Total Labor Force (in %) of 1993 in Small states to that in South Asia?
Your response must be concise. 1.44. What is the ratio of the Total Labor Force (in %) in 1990 in Small states to that in Sub-Saharan Africa (all income levels)?
Your response must be concise. 0.88. What is the ratio of the Total Labor Force (in %) of 1991 in Small states to that in Sub-Saharan Africa (all income levels)?
Offer a very short reply. 0.88. What is the ratio of the Total Labor Force (in %) of 1992 in Small states to that in Sub-Saharan Africa (all income levels)?
Provide a short and direct response. 0.88. What is the ratio of the Total Labor Force (in %) of 1993 in Small states to that in Sub-Saharan Africa (all income levels)?
Your answer should be very brief. 0.88. What is the ratio of the Total Labor Force (in %) of 1990 in South Asia to that in Sub-Saharan Africa (all income levels)?
Your answer should be very brief. 0.61. What is the ratio of the Total Labor Force (in %) of 1991 in South Asia to that in Sub-Saharan Africa (all income levels)?
Provide a short and direct response. 0.61. What is the ratio of the Total Labor Force (in %) of 1992 in South Asia to that in Sub-Saharan Africa (all income levels)?
Provide a short and direct response. 0.61. What is the ratio of the Total Labor Force (in %) in 1993 in South Asia to that in Sub-Saharan Africa (all income levels)?
Ensure brevity in your answer.  0.61. What is the difference between the highest and the second highest Total Labor Force (in %) in 1990?
Ensure brevity in your answer.  6.93. What is the difference between the highest and the second highest Total Labor Force (in %) in 1991?
Keep it short and to the point. 7.11. What is the difference between the highest and the second highest Total Labor Force (in %) of 1992?
Provide a short and direct response. 7.32. What is the difference between the highest and the second highest Total Labor Force (in %) in 1993?
Provide a short and direct response. 7.43. What is the difference between the highest and the lowest Total Labor Force (in %) in 1990?
Your answer should be very brief. 23.01. What is the difference between the highest and the lowest Total Labor Force (in %) of 1991?
Offer a very short reply. 23.07. What is the difference between the highest and the lowest Total Labor Force (in %) of 1992?
Provide a succinct answer. 23.29. What is the difference between the highest and the lowest Total Labor Force (in %) of 1993?
Give a very brief answer. 23.43. 